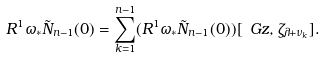<formula> <loc_0><loc_0><loc_500><loc_500>R ^ { 1 } \omega _ { * } \tilde { N } _ { n - 1 } ( 0 ) = \sum _ { k = 1 } ^ { n - 1 } ( R ^ { 1 } \omega _ { * } \tilde { N } _ { n - 1 } ( 0 ) ) [ \ G z , \zeta _ { \lambda + \nu _ { k } } ] .</formula> 